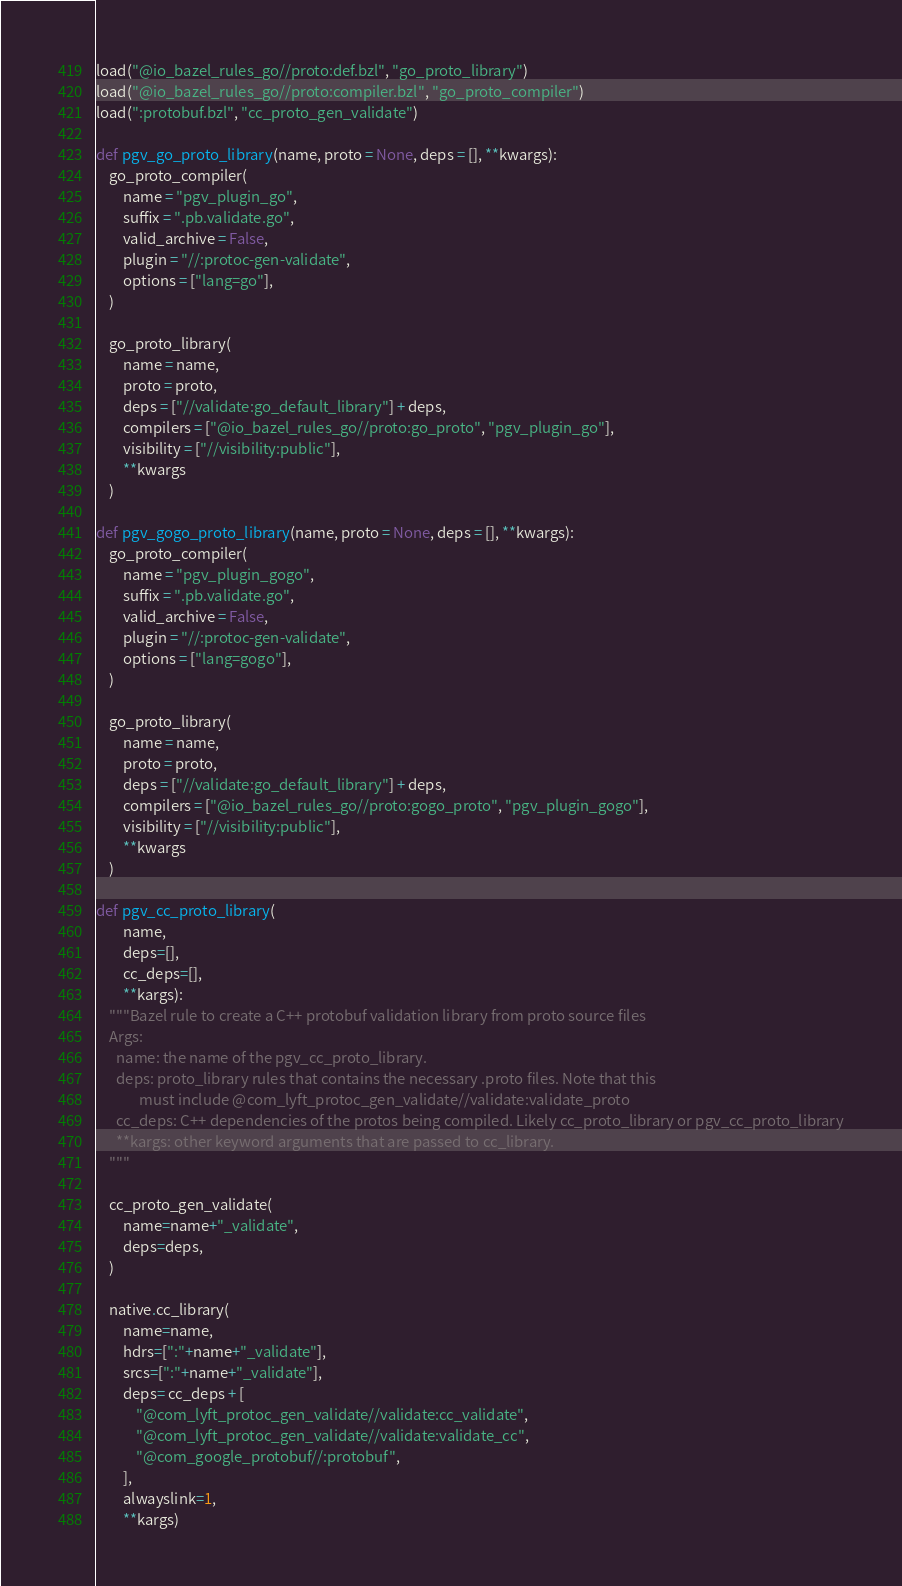Convert code to text. <code><loc_0><loc_0><loc_500><loc_500><_Python_>load("@io_bazel_rules_go//proto:def.bzl", "go_proto_library")
load("@io_bazel_rules_go//proto:compiler.bzl", "go_proto_compiler")
load(":protobuf.bzl", "cc_proto_gen_validate")

def pgv_go_proto_library(name, proto = None, deps = [], **kwargs):
    go_proto_compiler(
        name = "pgv_plugin_go",
        suffix = ".pb.validate.go",
        valid_archive = False,
        plugin = "//:protoc-gen-validate",
        options = ["lang=go"],
    )

    go_proto_library(
        name = name,
        proto = proto,
        deps = ["//validate:go_default_library"] + deps,
        compilers = ["@io_bazel_rules_go//proto:go_proto", "pgv_plugin_go"],
        visibility = ["//visibility:public"],
        **kwargs
    )

def pgv_gogo_proto_library(name, proto = None, deps = [], **kwargs):
    go_proto_compiler(
        name = "pgv_plugin_gogo",
        suffix = ".pb.validate.go",
        valid_archive = False,
        plugin = "//:protoc-gen-validate",
        options = ["lang=gogo"],
    )

    go_proto_library(
        name = name,
        proto = proto,
        deps = ["//validate:go_default_library"] + deps,
        compilers = ["@io_bazel_rules_go//proto:gogo_proto", "pgv_plugin_gogo"],
        visibility = ["//visibility:public"],
        **kwargs
    )

def pgv_cc_proto_library(
        name,
        deps=[],
        cc_deps=[],
        **kargs):
    """Bazel rule to create a C++ protobuf validation library from proto source files
    Args:
      name: the name of the pgv_cc_proto_library.
      deps: proto_library rules that contains the necessary .proto files. Note that this
             must include @com_lyft_protoc_gen_validate//validate:validate_proto
      cc_deps: C++ dependencies of the protos being compiled. Likely cc_proto_library or pgv_cc_proto_library
      **kargs: other keyword arguments that are passed to cc_library.
    """

    cc_proto_gen_validate(
        name=name+"_validate",
        deps=deps,
    )

    native.cc_library(
        name=name,
        hdrs=[":"+name+"_validate"],
        srcs=[":"+name+"_validate"],
        deps= cc_deps + [
            "@com_lyft_protoc_gen_validate//validate:cc_validate",
            "@com_lyft_protoc_gen_validate//validate:validate_cc",
            "@com_google_protobuf//:protobuf",
        ],
        alwayslink=1,
        **kargs)

</code> 